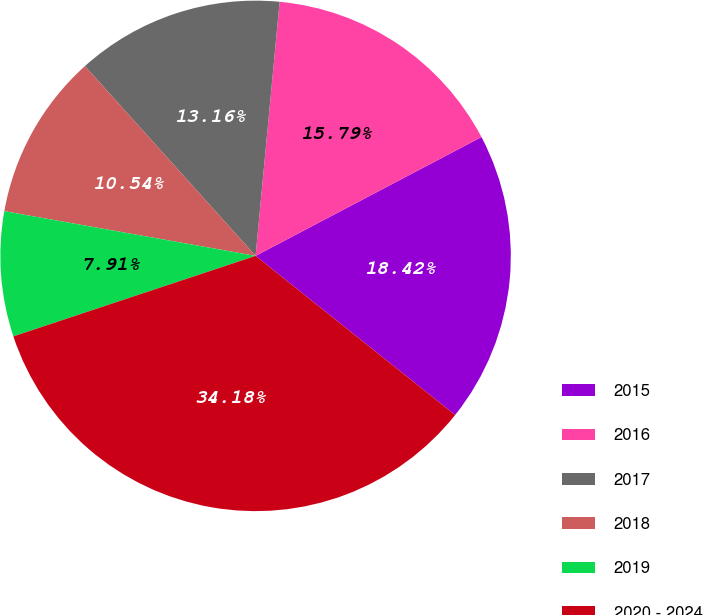Convert chart to OTSL. <chart><loc_0><loc_0><loc_500><loc_500><pie_chart><fcel>2015<fcel>2016<fcel>2017<fcel>2018<fcel>2019<fcel>2020 - 2024<nl><fcel>18.42%<fcel>15.79%<fcel>13.16%<fcel>10.54%<fcel>7.91%<fcel>34.18%<nl></chart> 